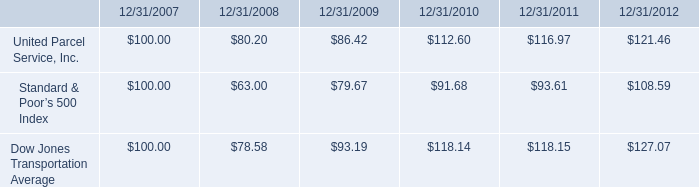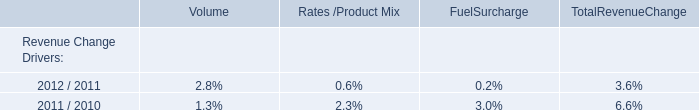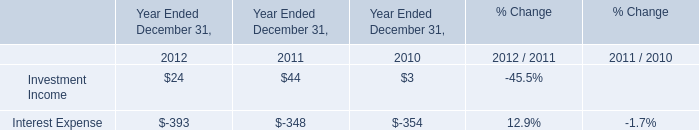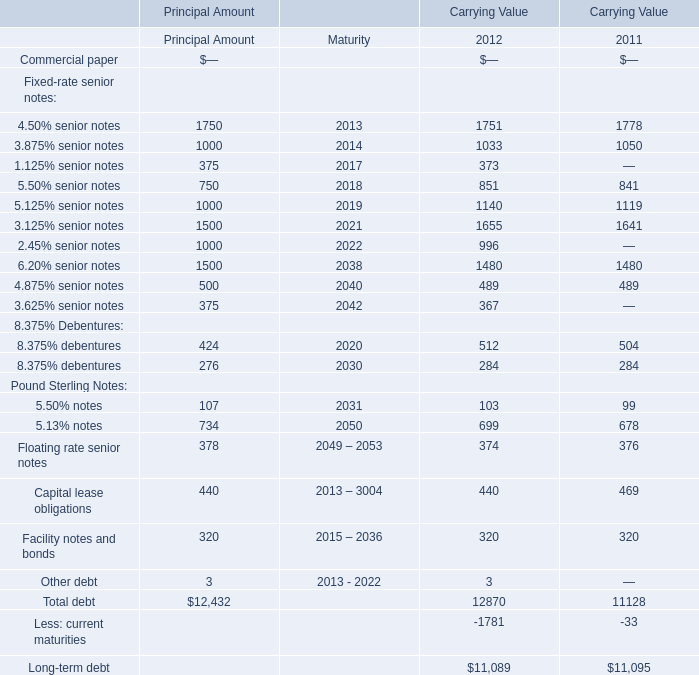what is the roi of an investment in s&p500 from 2008 to 2009? 
Computations: ((79.67 - 63.00) / 63.00)
Answer: 0.2646. 